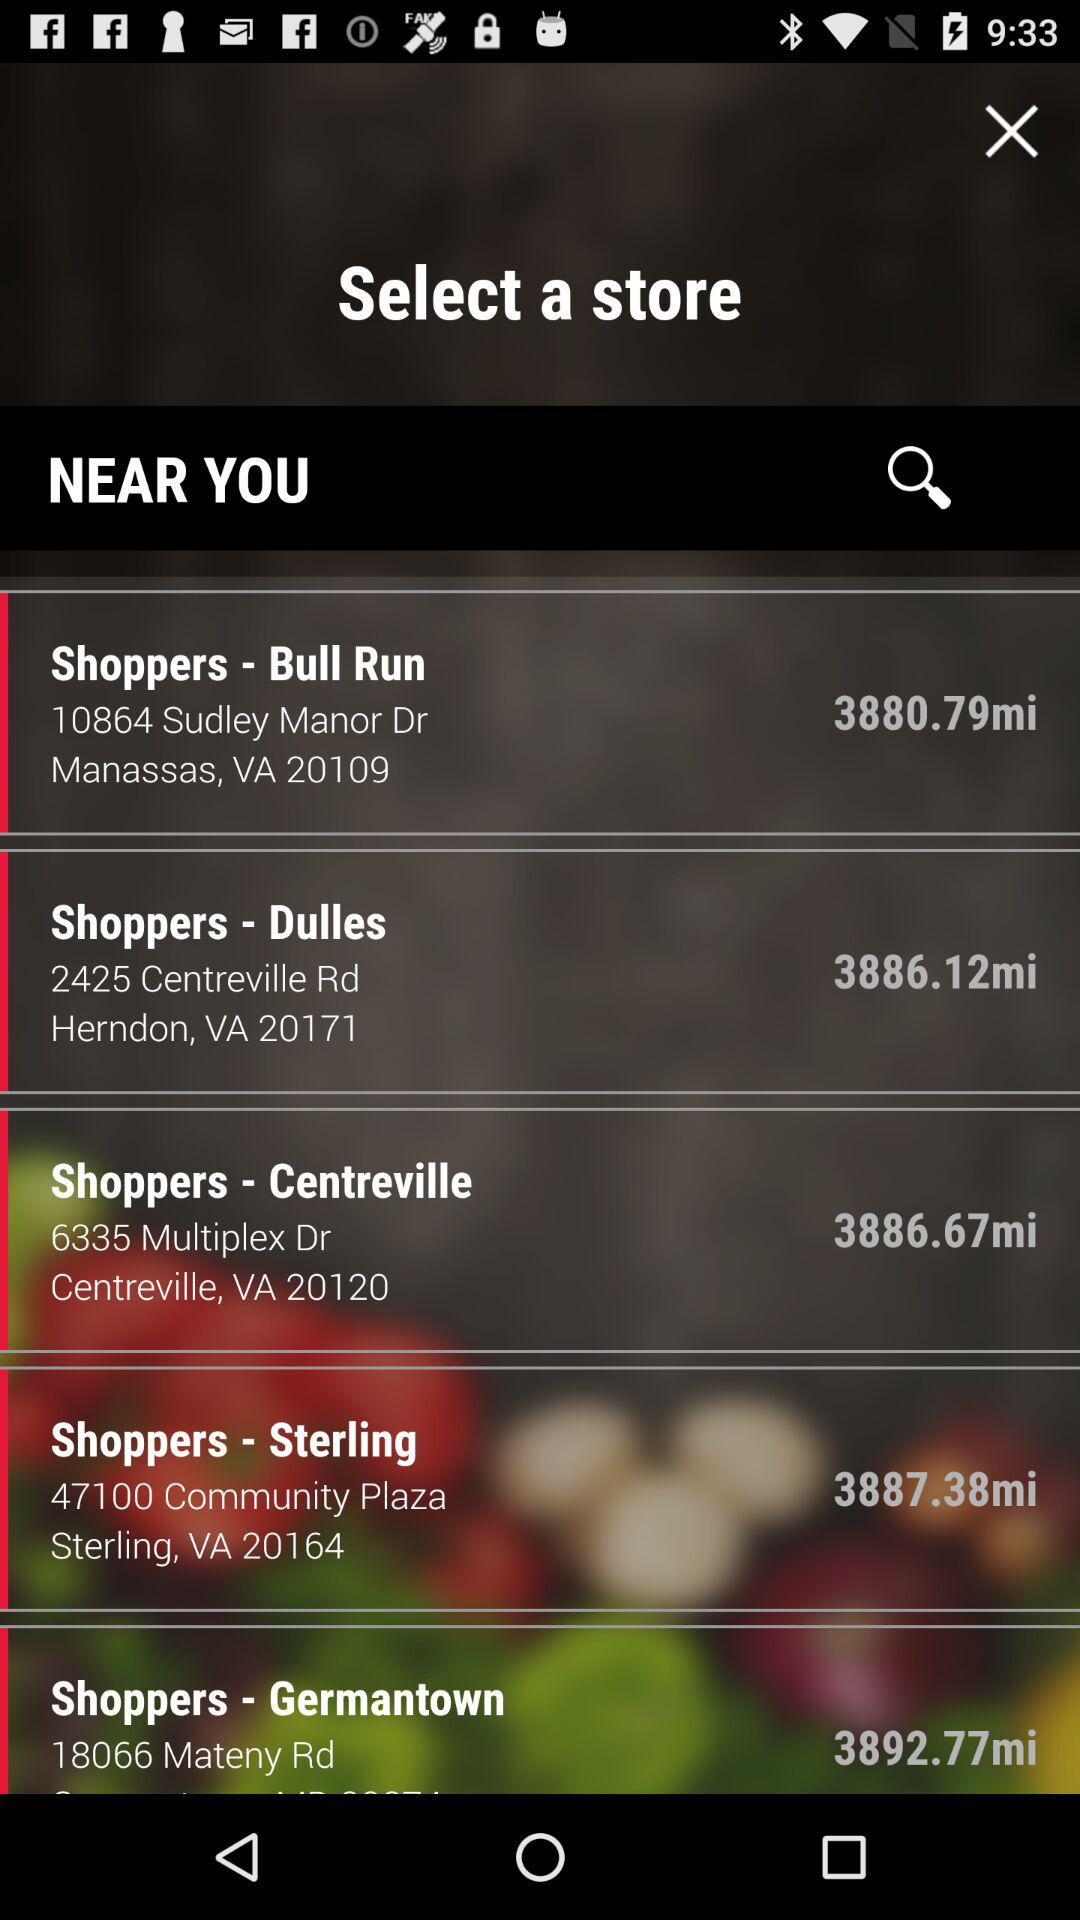What is the zip code of Sterling, VA? The zip code of Sterling, VA is 20164. 